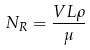<formula> <loc_0><loc_0><loc_500><loc_500>N _ { R } = \frac { V L \rho } { \mu }</formula> 